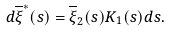Convert formula to latex. <formula><loc_0><loc_0><loc_500><loc_500>d \overline { \xi } ^ { * } ( s ) = \overline { \xi } _ { 2 } ( s ) K _ { 1 } ( s ) d s .</formula> 